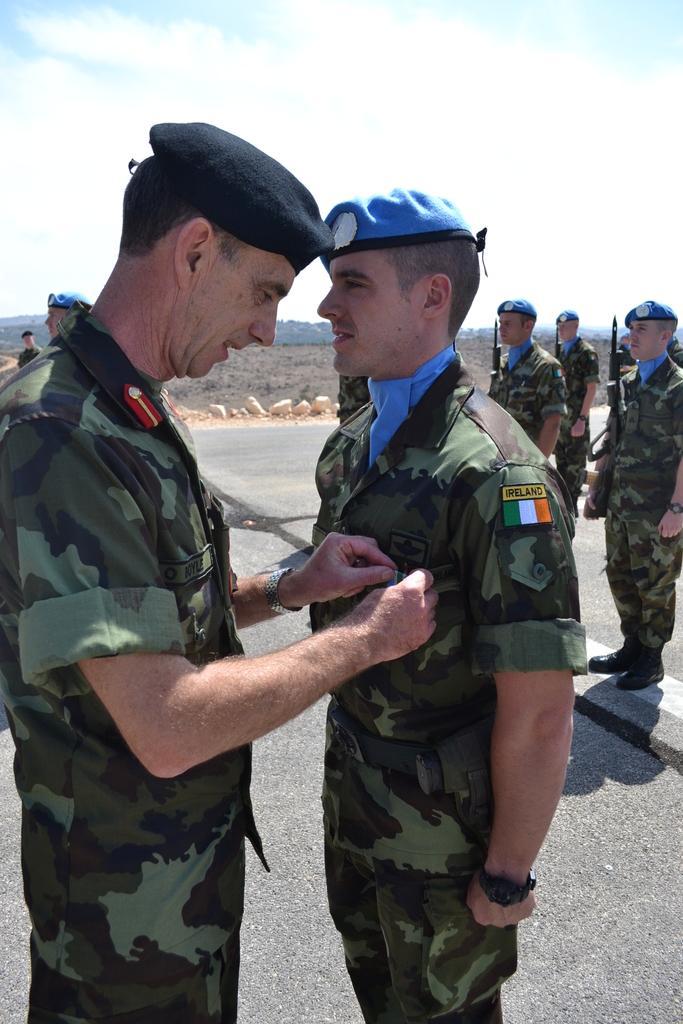Can you describe this image briefly? In this picture we see army standing on the ground. On the left side, we can see a senior army official pinning a badge on the chest of another army official. Here the sky is blue. 